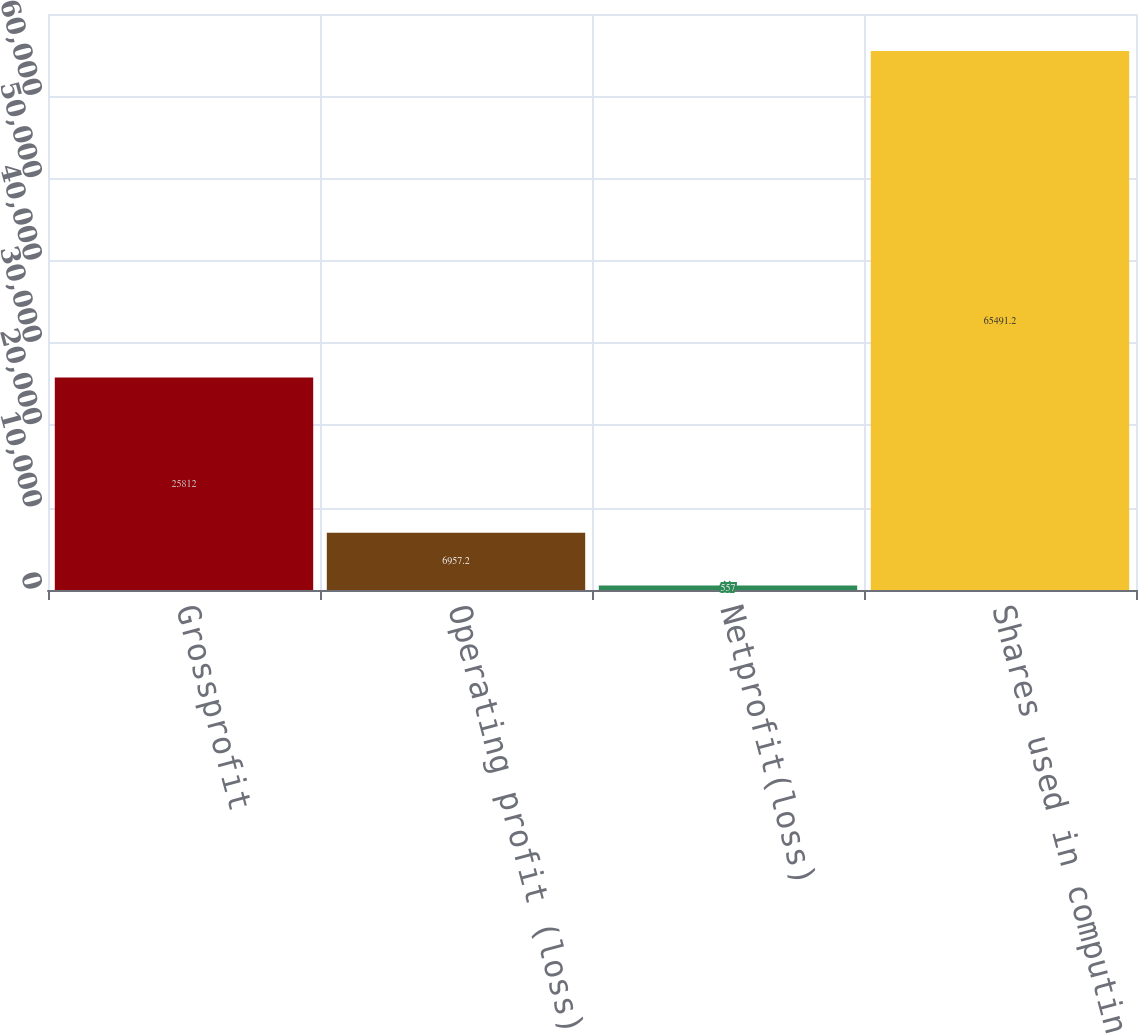Convert chart. <chart><loc_0><loc_0><loc_500><loc_500><bar_chart><fcel>Grossprofit<fcel>Operating profit (loss)<fcel>Netprofit(loss)<fcel>Shares used in computing per<nl><fcel>25812<fcel>6957.2<fcel>557<fcel>65491.2<nl></chart> 